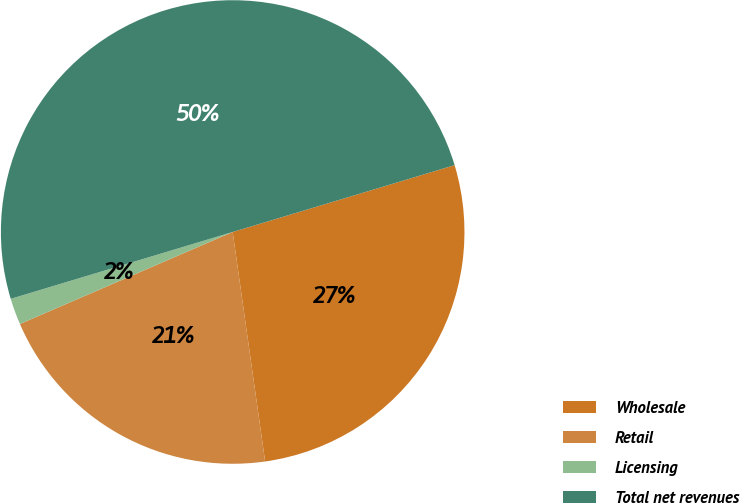Convert chart to OTSL. <chart><loc_0><loc_0><loc_500><loc_500><pie_chart><fcel>Wholesale<fcel>Retail<fcel>Licensing<fcel>Total net revenues<nl><fcel>27.42%<fcel>20.74%<fcel>1.84%<fcel>50.0%<nl></chart> 